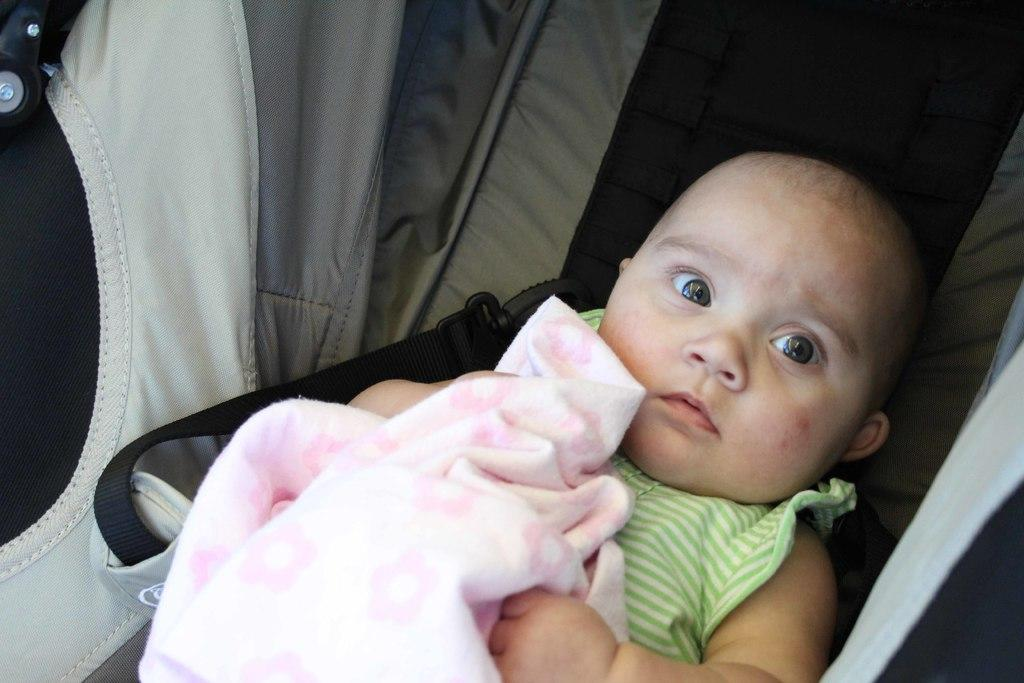What is the main subject in the foreground of the image? There is a baby in the baby cart in the foreground of the image. How is the baby dressed or covered in the image? The baby is covered with a pink cloth. What type of jewel is the baby wearing on their feet in the image? There is no jewel visible on the baby's feet in the image. What kind of plant is growing next to the baby cart in the image? There is no plant visible next to the baby cart in the image. 